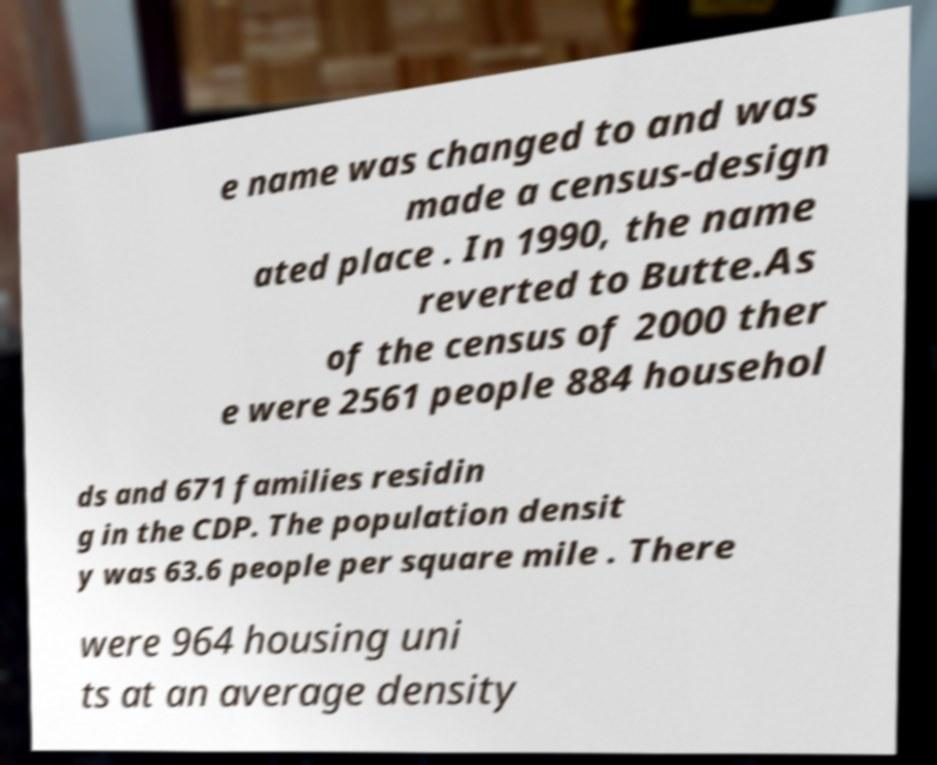For documentation purposes, I need the text within this image transcribed. Could you provide that? e name was changed to and was made a census-design ated place . In 1990, the name reverted to Butte.As of the census of 2000 ther e were 2561 people 884 househol ds and 671 families residin g in the CDP. The population densit y was 63.6 people per square mile . There were 964 housing uni ts at an average density 